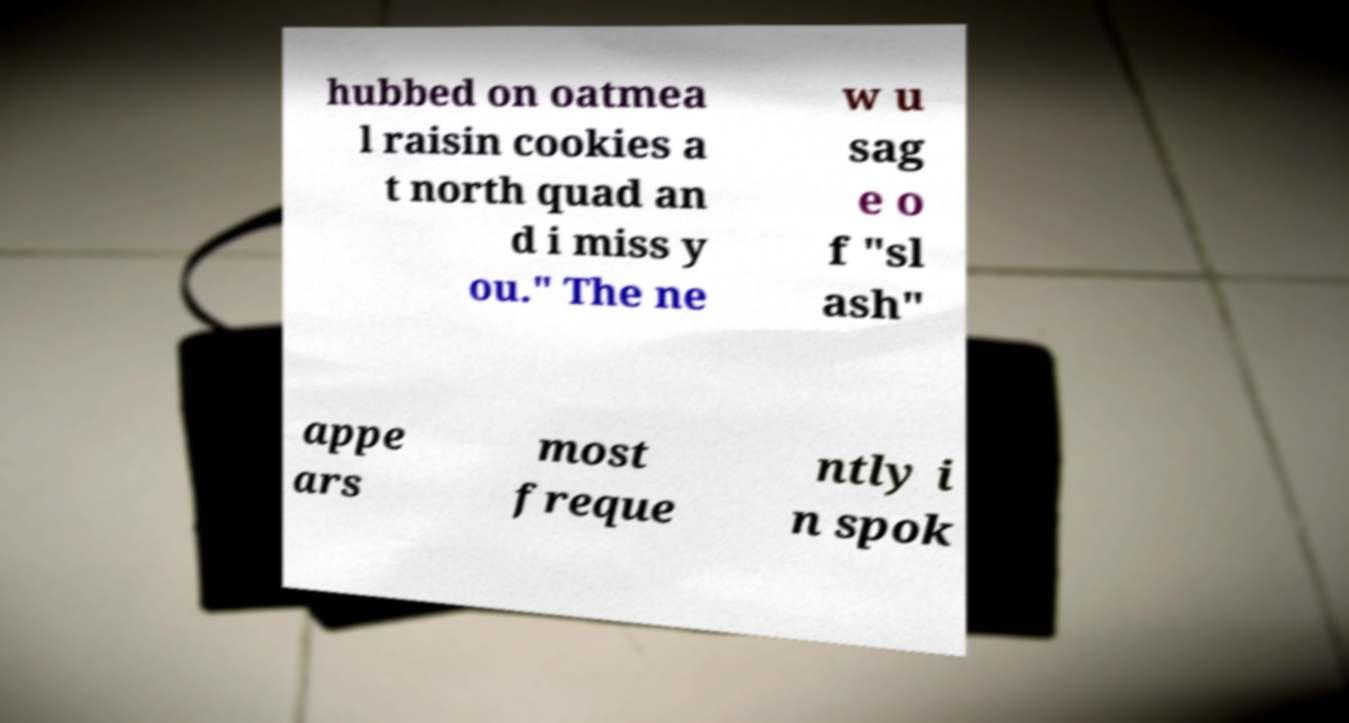Could you extract and type out the text from this image? hubbed on oatmea l raisin cookies a t north quad an d i miss y ou." The ne w u sag e o f "sl ash" appe ars most freque ntly i n spok 